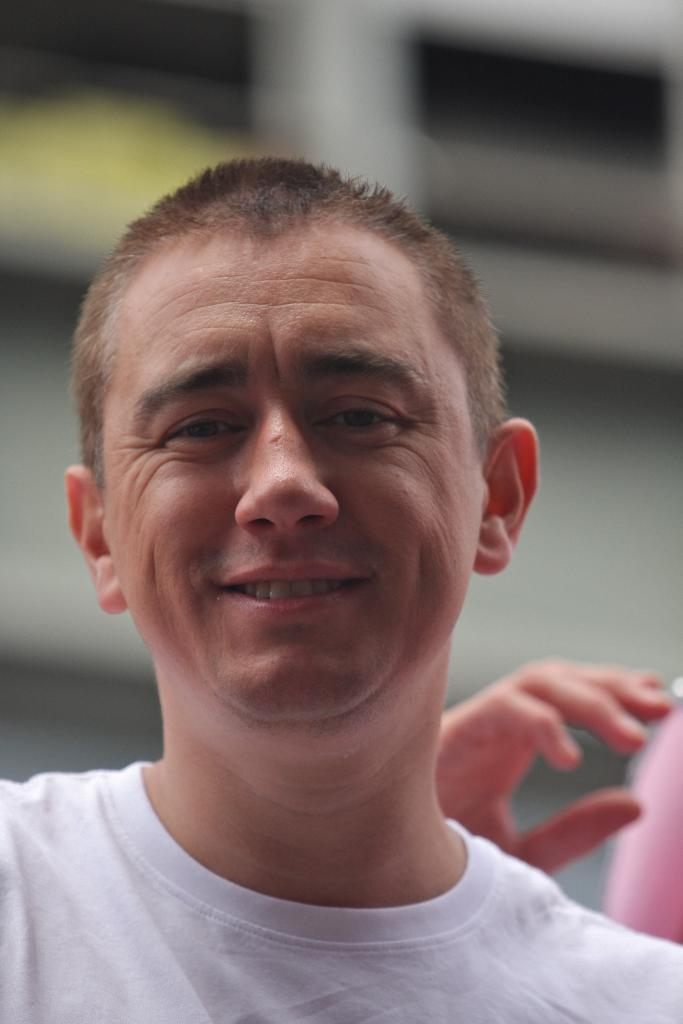What is the main subject of the image? There is a man in the image. Can you describe any specific details about the man? The hand of a person is visible on the backside of the man. What type of connection or support does the man provide in the image? There is no indication in the image that the man is providing any connection or support. 